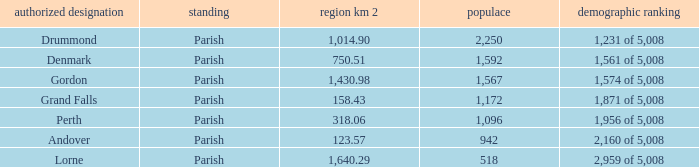What is the area of the parish with a population larger than 1,172 and a census ranking of 1,871 of 5,008? 0.0. 